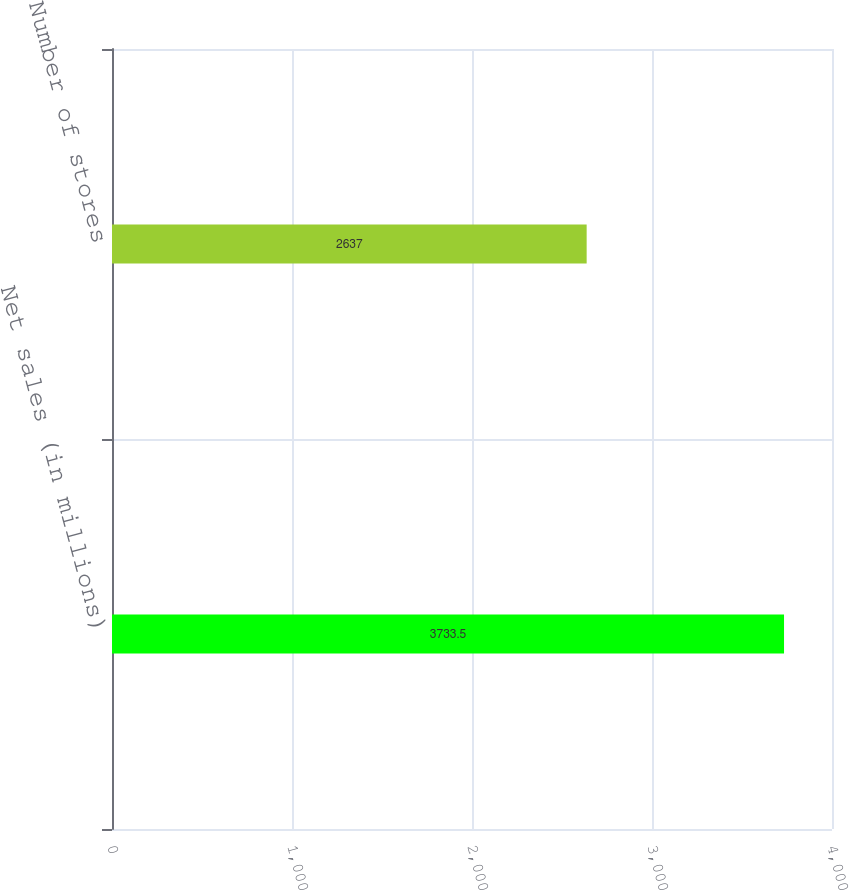Convert chart to OTSL. <chart><loc_0><loc_0><loc_500><loc_500><bar_chart><fcel>Net sales (in millions)<fcel>Number of stores<nl><fcel>3733.5<fcel>2637<nl></chart> 